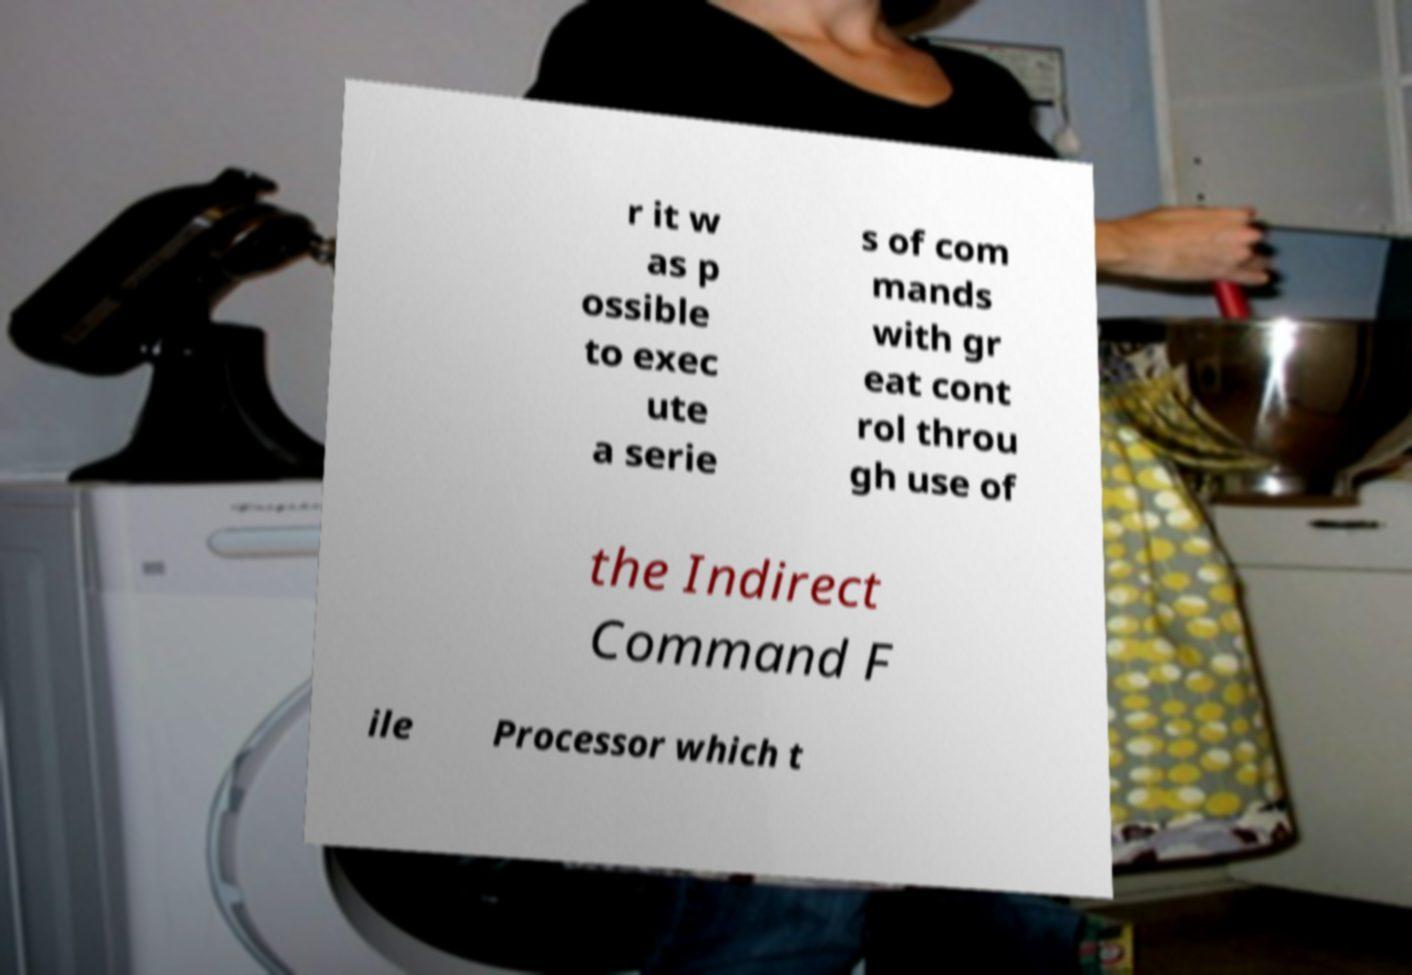Could you assist in decoding the text presented in this image and type it out clearly? r it w as p ossible to exec ute a serie s of com mands with gr eat cont rol throu gh use of the Indirect Command F ile Processor which t 